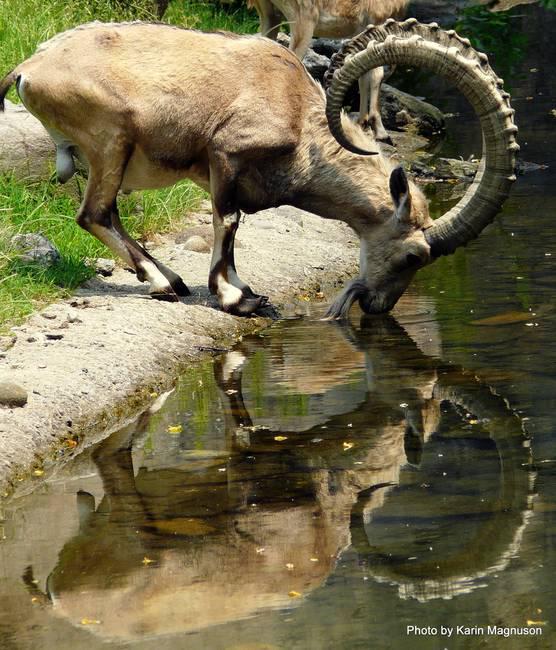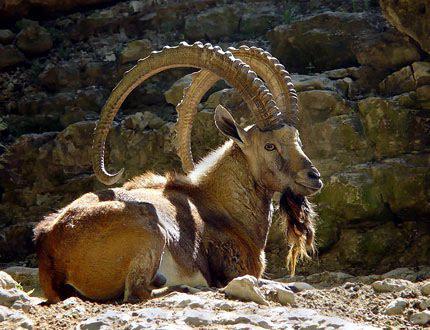The first image is the image on the left, the second image is the image on the right. Given the left and right images, does the statement "Horned rams in the  pair of images are facing toward each other." hold true? Answer yes or no. No. 